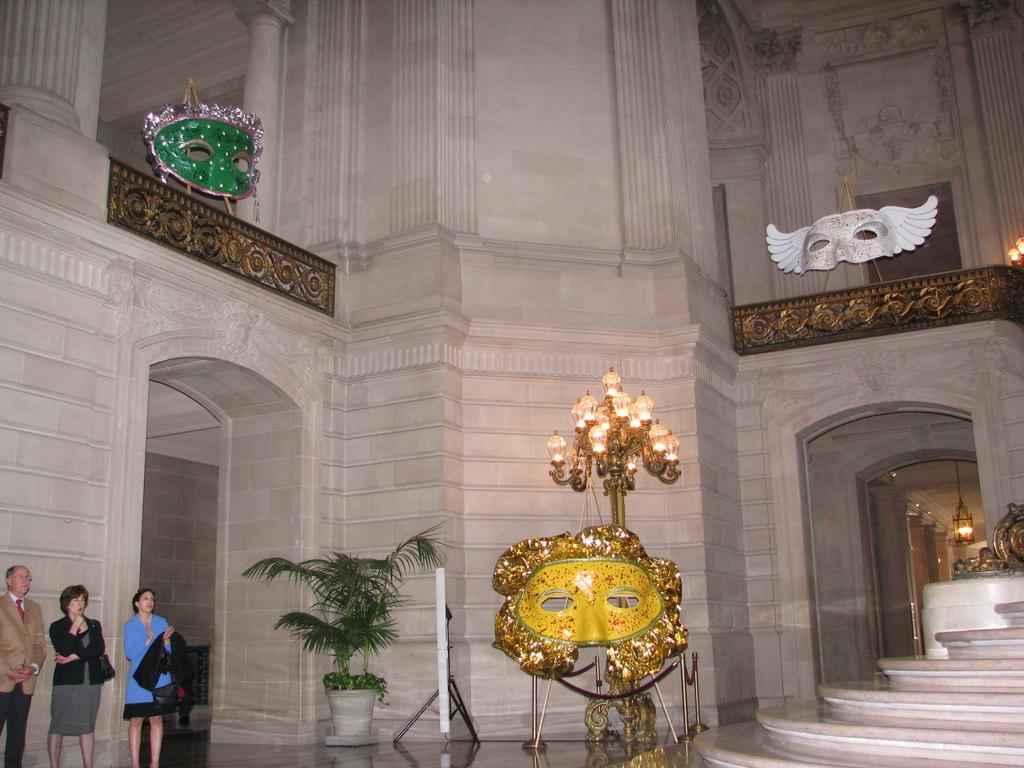What type of location is depicted in the image? The image shows an inside view of a building. How many people are present in the image? There are three people standing in the image. What kind of plant can be seen in the image? There is a house plant in the image. Can you describe the lighting in the image? Lights are visible in the image. What architectural feature is present in the image? There are steps in the image. What structural elements are present in the image? Walls are present in the image. What safety precautions are being taken by the people in the image? Face masks are visible in the image. What additional feature can be seen in the image? Railings are present in the image. What other objects are present in the image? There are some objects in the image. What type of sea creature can be seen swimming in the image? There is no sea creature present in the image; it shows an inside view of a building. 